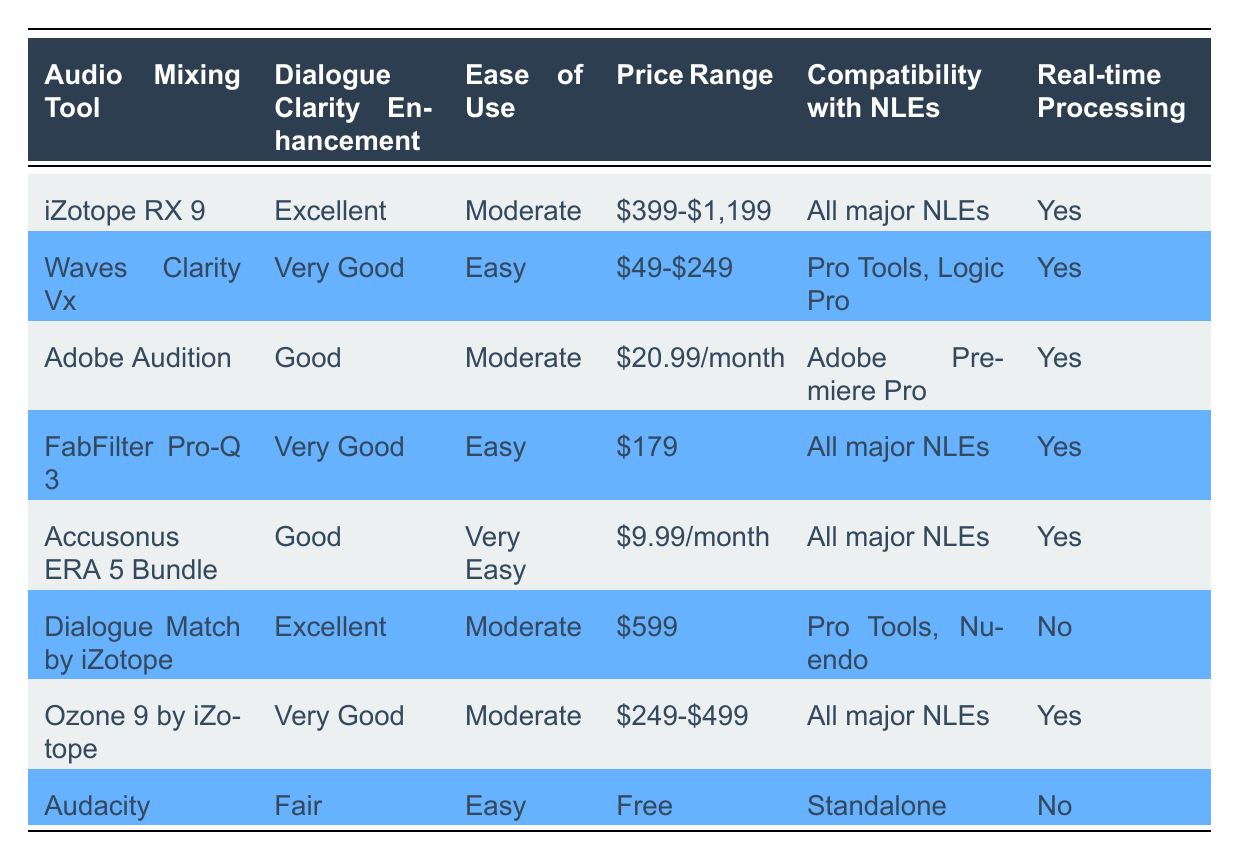What is the price range of iZotope RX 9? The price range for iZotope RX 9 is explicitly listed in the table under the "Price Range" column. It states that the price is between 399 and 1,199 dollars.
Answer: 399-$1,199 Which tool offers "Very Easy" ease of use? When reviewing the "Ease of Use" column, Accusonus ERA 5 Bundle is the only tool that is rated as "Very Easy."
Answer: Accusonus ERA 5 Bundle Is Adobe Audition compatible with all major NLEs? According to the "Compatibility with NLEs" column, Adobe Audition is compatible only with Adobe Premiere Pro. Since it's not compatible with all major NLEs, the answer is no.
Answer: No Which audio mixing tool has the highest price range? The price ranges need to be compared, focusing on iZotope RX 9 ($399-$1,199), which is the only item with a range that includes the highest value of 1,199 dollars. Therefore, it has the highest price range among the listed tools.
Answer: iZotope RX 9 Which two tools provide excellent dialogue clarity enhancement? The table shows that both iZotope RX 9 and Dialogue Match by iZotope have "Excellent" listed in the "Dialogue Clarity Enhancement" column.
Answer: iZotope RX 9, Dialogue Match by iZotope What is the average price range of the tools that are rated "Very Good"? The tools rated "Very Good" are Waves Clarity Vx ($49-$249) and Ozone 9 by iZotope ($249-$499). To find the average, we take the highest and lowest values of both ranges ($249 and $49, and $499 and $249). Averaging the lower bounds gives ($49 + $249)/2 = $149, and for the upper bounds, ($249 + $499)/2 = $374. The overall average price range would vary, but a midpoint summarization can be described.
Answer: Average range can be approximated as $399 Does iZotope RX 9 have real-time processing capability? The "Real-time Processing" column indicates that iZotope RX 9 is marked "Yes," confirming it does have real-time processing capability.
Answer: Yes Which audio mixing tools can be used with Pro Tools? By examining the "Compatibility with NLEs" column, the tools that are compatible with Pro Tools are Waves Clarity Vx and Dialogue Match by iZotope.
Answer: Waves Clarity Vx, Dialogue Match by iZotope Which tool is free? In the "Price Range" column, Audacity is the only tool that is listed as "Free."
Answer: Audacity 